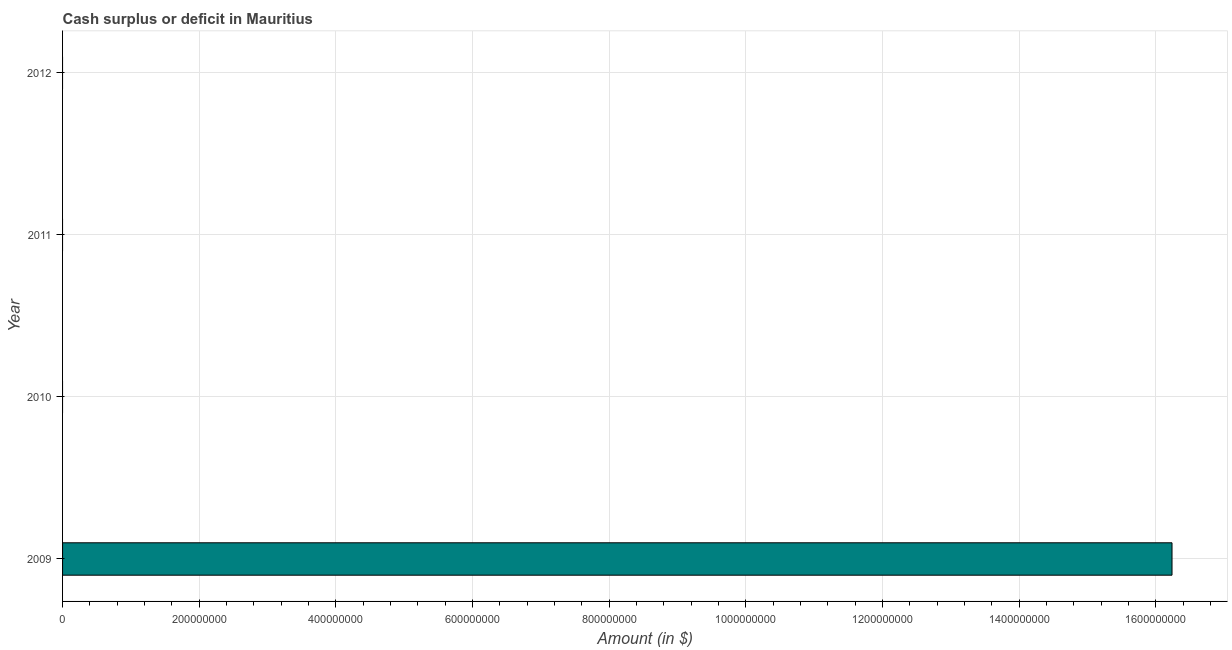Does the graph contain any zero values?
Your response must be concise. Yes. Does the graph contain grids?
Your response must be concise. Yes. What is the title of the graph?
Your answer should be compact. Cash surplus or deficit in Mauritius. What is the label or title of the X-axis?
Give a very brief answer. Amount (in $). What is the label or title of the Y-axis?
Your response must be concise. Year. What is the cash surplus or deficit in 2010?
Your answer should be very brief. 0. Across all years, what is the maximum cash surplus or deficit?
Your answer should be compact. 1.62e+09. Across all years, what is the minimum cash surplus or deficit?
Your answer should be compact. 0. What is the sum of the cash surplus or deficit?
Your response must be concise. 1.62e+09. What is the average cash surplus or deficit per year?
Provide a succinct answer. 4.06e+08. What is the difference between the highest and the lowest cash surplus or deficit?
Offer a terse response. 1.62e+09. In how many years, is the cash surplus or deficit greater than the average cash surplus or deficit taken over all years?
Your response must be concise. 1. Are all the bars in the graph horizontal?
Make the answer very short. Yes. What is the difference between two consecutive major ticks on the X-axis?
Provide a short and direct response. 2.00e+08. What is the Amount (in $) in 2009?
Provide a short and direct response. 1.62e+09. What is the Amount (in $) of 2011?
Provide a succinct answer. 0. 